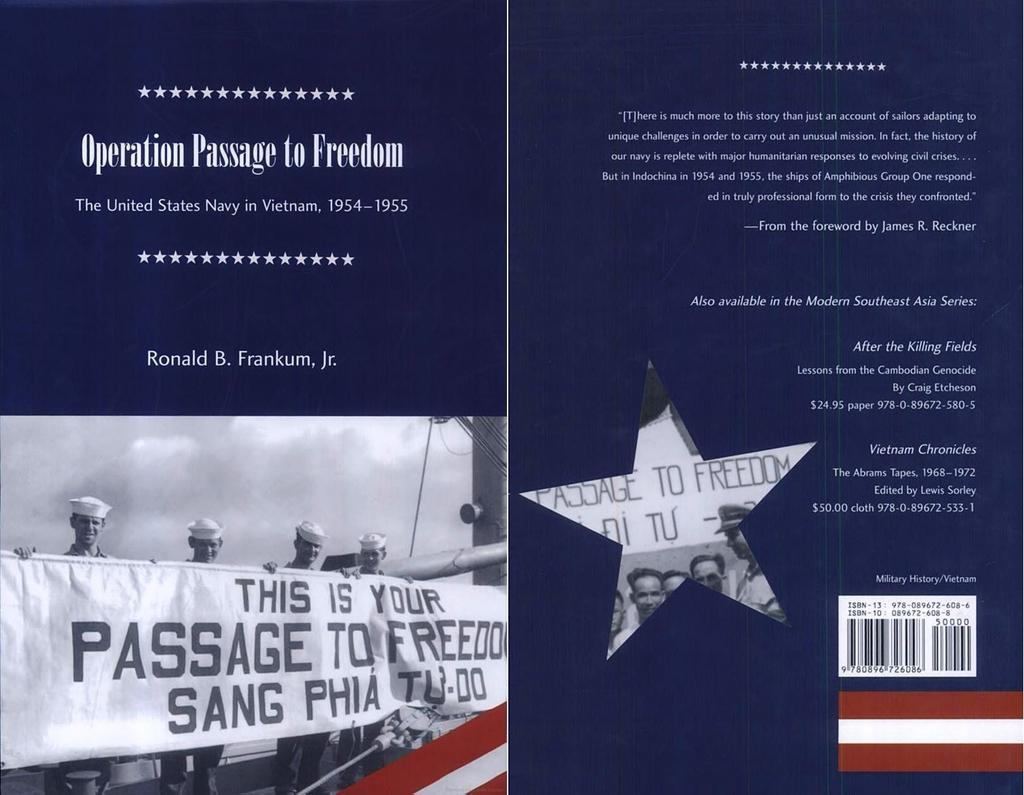How would you summarize this image in a sentence or two? This image consists of a poster on which I can see some text and a picture of four persons who are holding a banner in their hands. On the top of this picture I can see in the sky. 